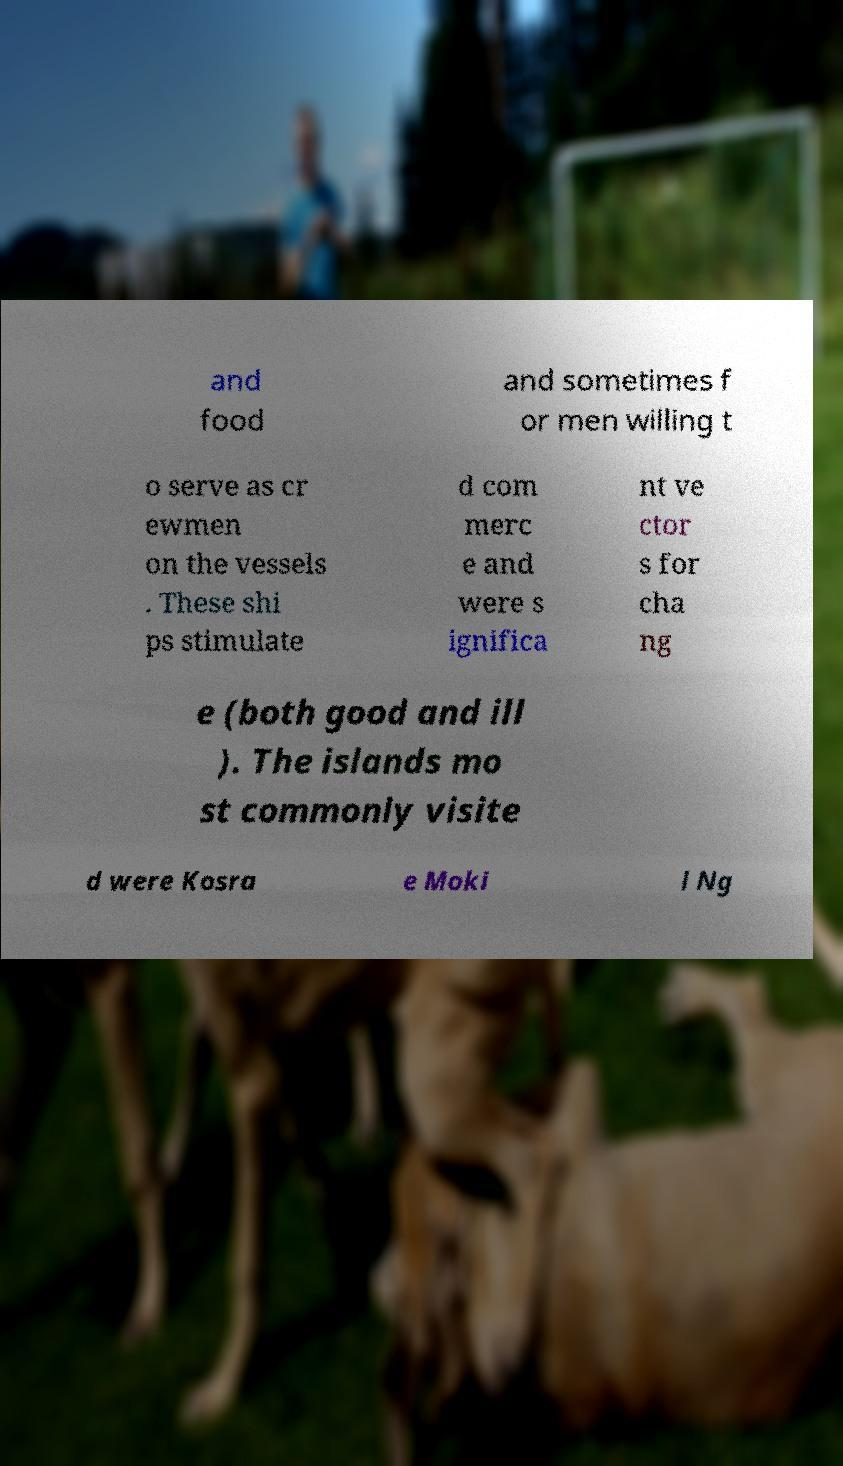What messages or text are displayed in this image? I need them in a readable, typed format. and food and sometimes f or men willing t o serve as cr ewmen on the vessels . These shi ps stimulate d com merc e and were s ignifica nt ve ctor s for cha ng e (both good and ill ). The islands mo st commonly visite d were Kosra e Moki l Ng 